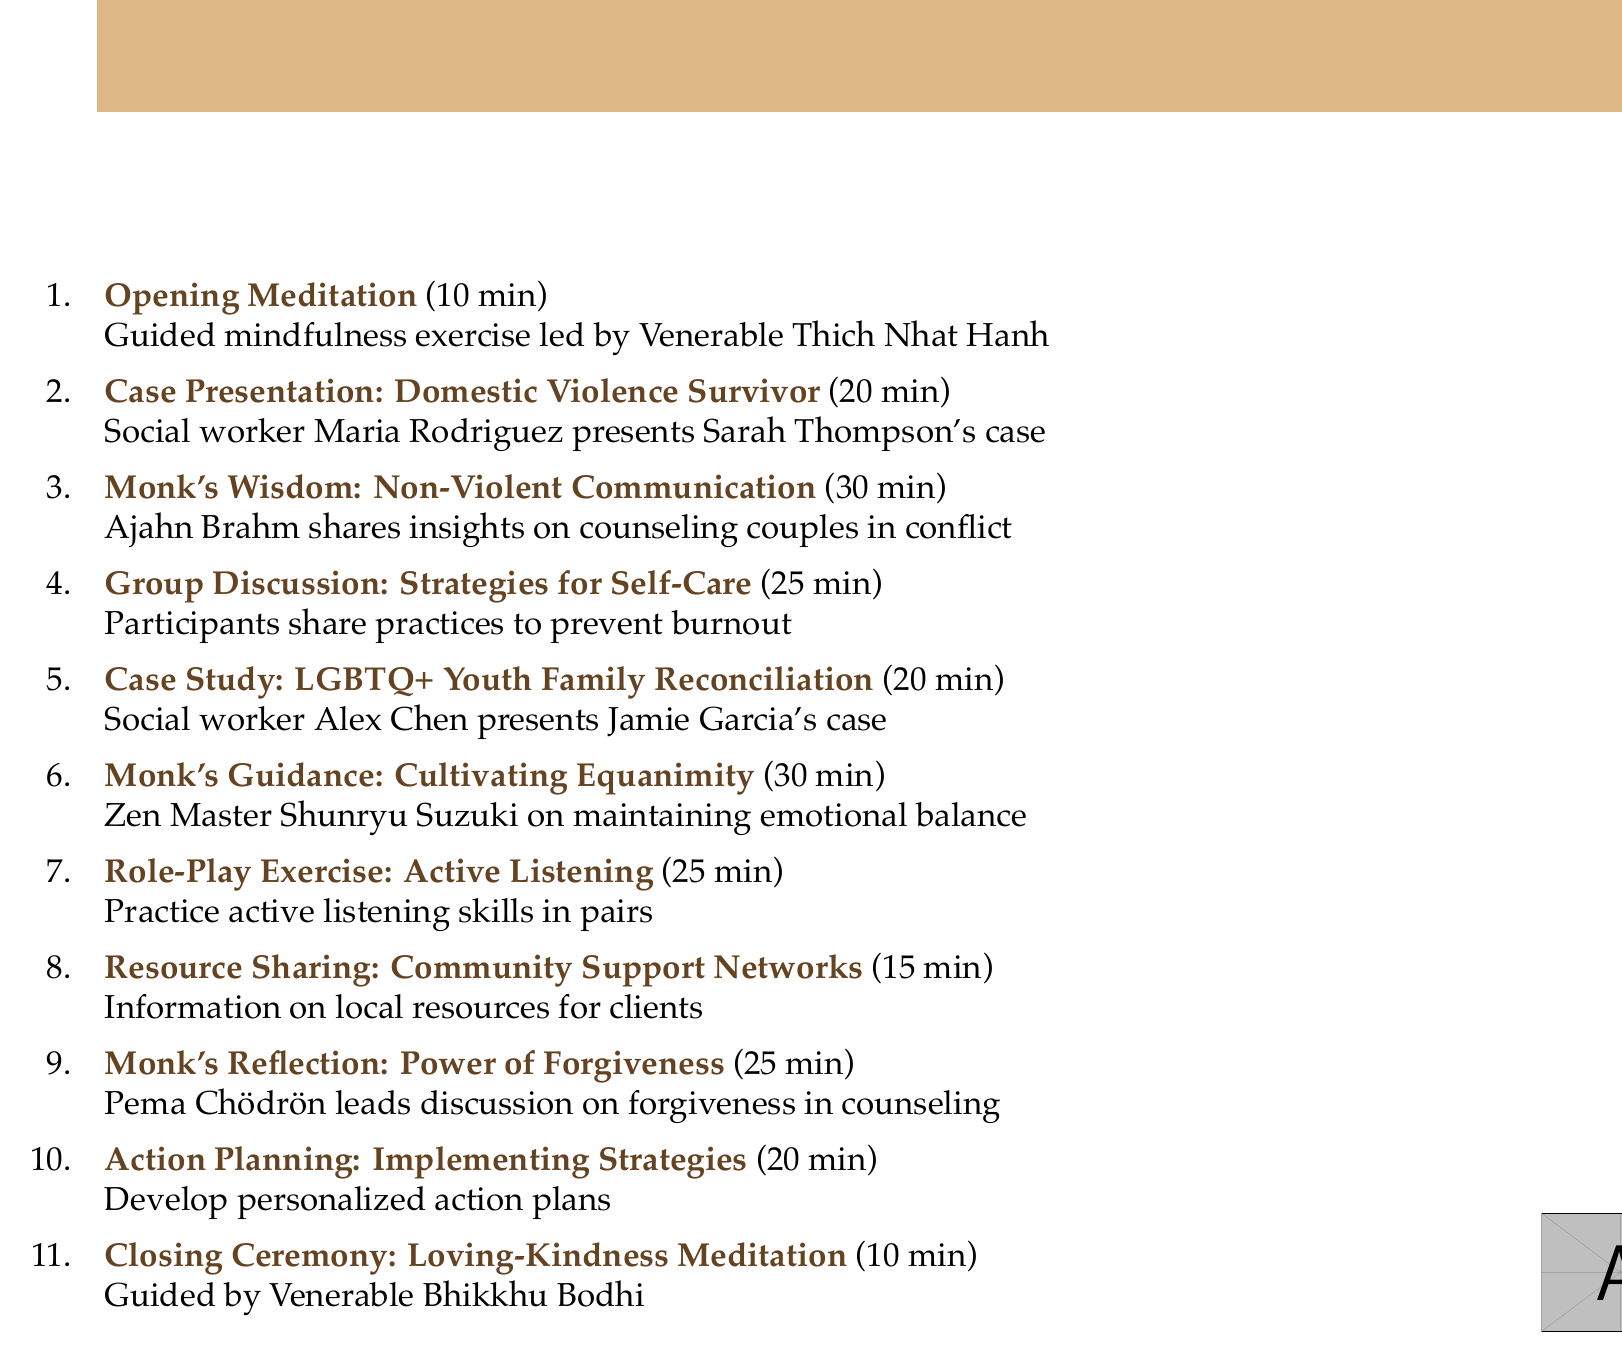What is the duration of the Opening Meditation? The duration is specifically mentioned in the agenda as 10 minutes.
Answer: 10 minutes Who presents the case of Sarah Thompson? The document lists social worker Maria Rodriguez as the presenter of Sarah Thompson's case.
Answer: Maria Rodriguez What is the title of the session where Ajahn Brahm shares insights? The session is titled "Monk's Wisdom: Non-Violent Communication Techniques".
Answer: Monk's Wisdom: Non-Violent Communication Techniques How long is the Group Discussion: Strategies for Self-Care? The document specifies the duration of this group discussion as 25 minutes.
Answer: 25 minutes What is the main focus of the Role-Play Exercise? The exercise is intended for practicing active listening skills using real client experiences.
Answer: Active listening skills What theme does Pema Chödrön address in her session? Pema Chödrön leads a discussion on incorporating forgiveness practices in relationship counseling.
Answer: Forgiveness practices What type of community resources are shared in the agenda? The document mentions information about local resources such as the Women's Aid Federation and PFLAG support groups.
Answer: Community support networks Which monk guides the Closing Ceremony? The Closing Ceremony is guided by Venerable Bhikkhu Bodhi.
Answer: Venerable Bhikkhu Bodhi How many case presentations are included in the agenda? There are two case presentations mentioned in the agenda: one for Domestic Violence Survivor and one for LGBTQ+ Youth Family Reconciliation.
Answer: Two 